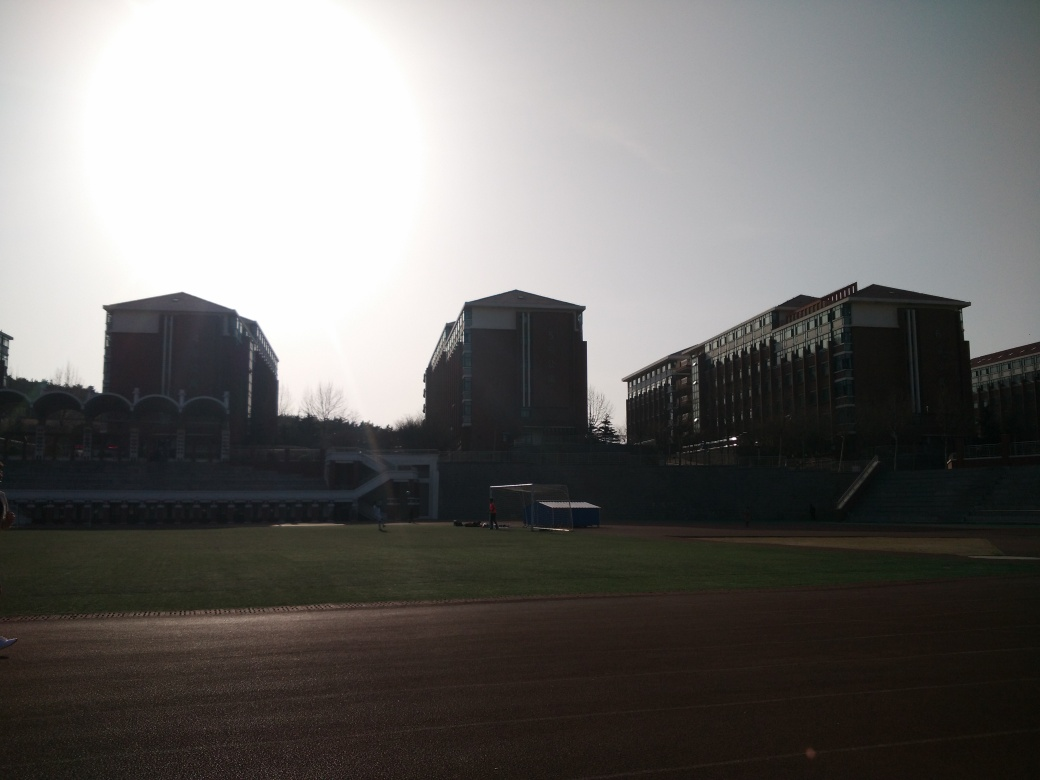Can you describe the architectural style of the buildings? The buildings exhibit a modern architectural style with symmetrically aligned windows and clean, straight lines. The flat roofs and the use of repetitive geometric shapes suggest a contemporary design that prioritizes functionality. 